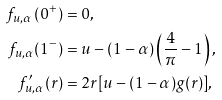<formula> <loc_0><loc_0><loc_500><loc_500>f _ { u , \alpha } \left ( 0 ^ { + } \right ) & = 0 , \\ f _ { u , \alpha } ( 1 ^ { - } ) & = u - ( 1 - \alpha ) \left ( \frac { 4 } { \pi } - 1 \right ) , \\ f _ { u , \alpha } ^ { \prime } ( r ) & = 2 r [ u - ( 1 - \alpha ) g ( r ) ] ,</formula> 